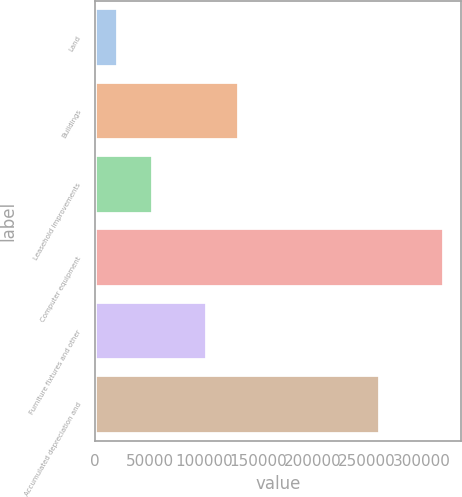Convert chart. <chart><loc_0><loc_0><loc_500><loc_500><bar_chart><fcel>Land<fcel>Buildings<fcel>Leasehold improvements<fcel>Computer equipment<fcel>Furniture fixtures and other<fcel>Accumulated depreciation and<nl><fcel>20735<fcel>132421<fcel>52932<fcel>320365<fcel>102458<fcel>261690<nl></chart> 